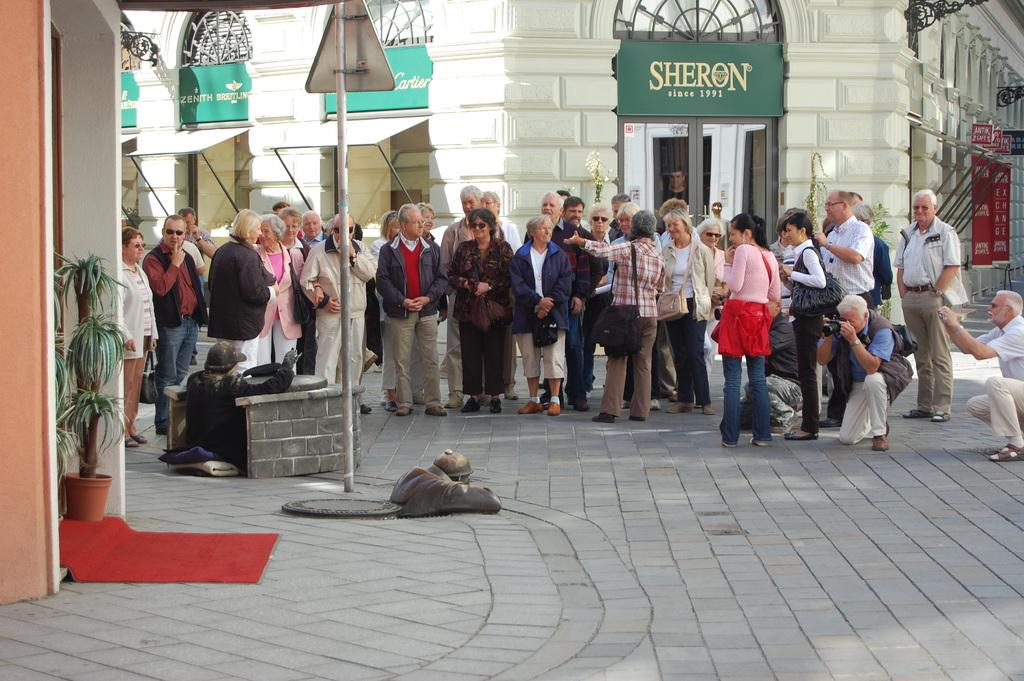What is in the foreground of the image? In the foreground of the image, there is pavement, plants, a carpet, and a wall. What else can be seen in the foreground of the image? There is also a road in the foreground of the image. What is visible in the middle of the image? In the middle of the image, there are people and other objects. What can be seen in the background of the image? In the background of the image, there are buildings. What type of party is happening in the image? There is no party happening in the image; it features a scene with pavement, plants, a carpet, a wall, a road, people, and buildings. How many people are in the crowd in the image? There is no crowd in the image; it shows individual people and objects. 